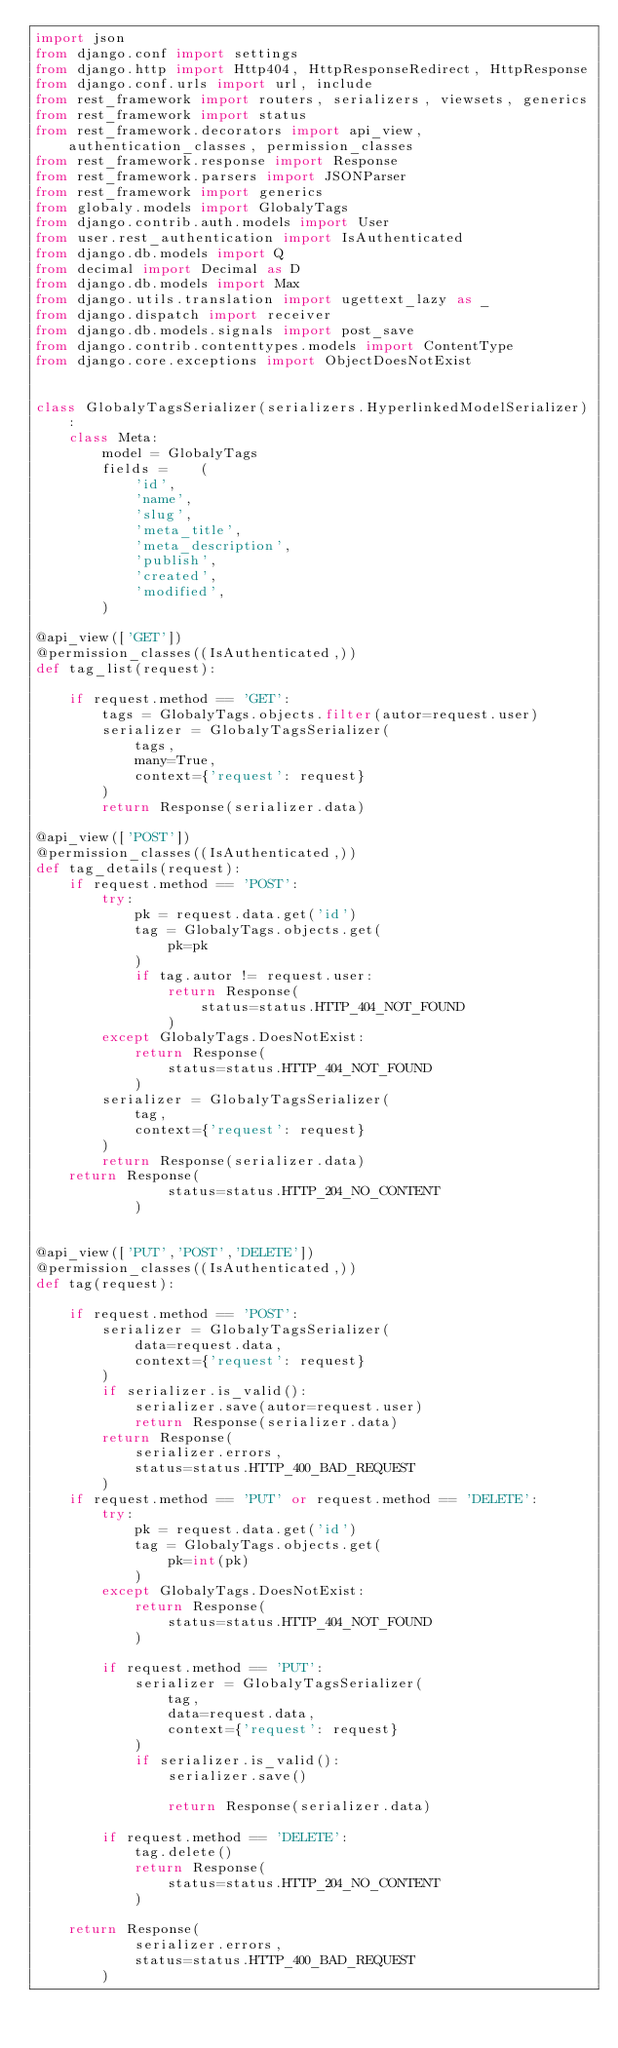<code> <loc_0><loc_0><loc_500><loc_500><_Python_>import json
from django.conf import settings
from django.http import Http404, HttpResponseRedirect, HttpResponse
from django.conf.urls import url, include
from rest_framework import routers, serializers, viewsets, generics
from rest_framework import status
from rest_framework.decorators import api_view, authentication_classes, permission_classes
from rest_framework.response import Response
from rest_framework.parsers import JSONParser
from rest_framework import generics
from globaly.models import GlobalyTags
from django.contrib.auth.models import User
from user.rest_authentication import IsAuthenticated
from django.db.models import Q
from decimal import Decimal as D
from django.db.models import Max
from django.utils.translation import ugettext_lazy as _
from django.dispatch import receiver
from django.db.models.signals import post_save
from django.contrib.contenttypes.models import ContentType
from django.core.exceptions import ObjectDoesNotExist


class GlobalyTagsSerializer(serializers.HyperlinkedModelSerializer):
    class Meta:
        model = GlobalyTags
        fields =    (
            'id', 
            'name',
            'slug',
            'meta_title',
            'meta_description',
            'publish',
            'created', 
            'modified',
        )

@api_view(['GET'])
@permission_classes((IsAuthenticated,))
def tag_list(request):

    if request.method == 'GET':
        tags = GlobalyTags.objects.filter(autor=request.user)
        serializer = GlobalyTagsSerializer(
            tags, 
            many=True,
            context={'request': request}
        )
        return Response(serializer.data)

@api_view(['POST'])
@permission_classes((IsAuthenticated,))
def tag_details(request):
    if request.method == 'POST':
        try:
            pk = request.data.get('id')
            tag = GlobalyTags.objects.get(
                pk=pk
            )
            if tag.autor != request.user:
                return Response(
                    status=status.HTTP_404_NOT_FOUND
                )
        except GlobalyTags.DoesNotExist:
            return Response(
                status=status.HTTP_404_NOT_FOUND
            )
        serializer = GlobalyTagsSerializer(
            tag,
            context={'request': request}
        )
        return Response(serializer.data)
    return Response(
                status=status.HTTP_204_NO_CONTENT
            )


@api_view(['PUT','POST','DELETE'])
@permission_classes((IsAuthenticated,))
def tag(request):
    
    if request.method == 'POST':
        serializer = GlobalyTagsSerializer(
            data=request.data,
            context={'request': request}
        )
        if serializer.is_valid():
            serializer.save(autor=request.user)
            return Response(serializer.data)
        return Response(
            serializer.errors, 
            status=status.HTTP_400_BAD_REQUEST
        )      
    if request.method == 'PUT' or request.method == 'DELETE':
        try:
            pk = request.data.get('id')
            tag = GlobalyTags.objects.get(
                pk=int(pk)
            )
        except GlobalyTags.DoesNotExist:
            return Response(
                status=status.HTTP_404_NOT_FOUND
            )

        if request.method == 'PUT':
            serializer = GlobalyTagsSerializer(
                tag,
                data=request.data,
                context={'request': request}
            )
            if serializer.is_valid():
                serializer.save()
                
                return Response(serializer.data)

        if request.method == 'DELETE':
            tag.delete()
            return Response(
                status=status.HTTP_204_NO_CONTENT
            )

    return Response(
            serializer.errors, 
            status=status.HTTP_400_BAD_REQUEST
        )    
</code> 